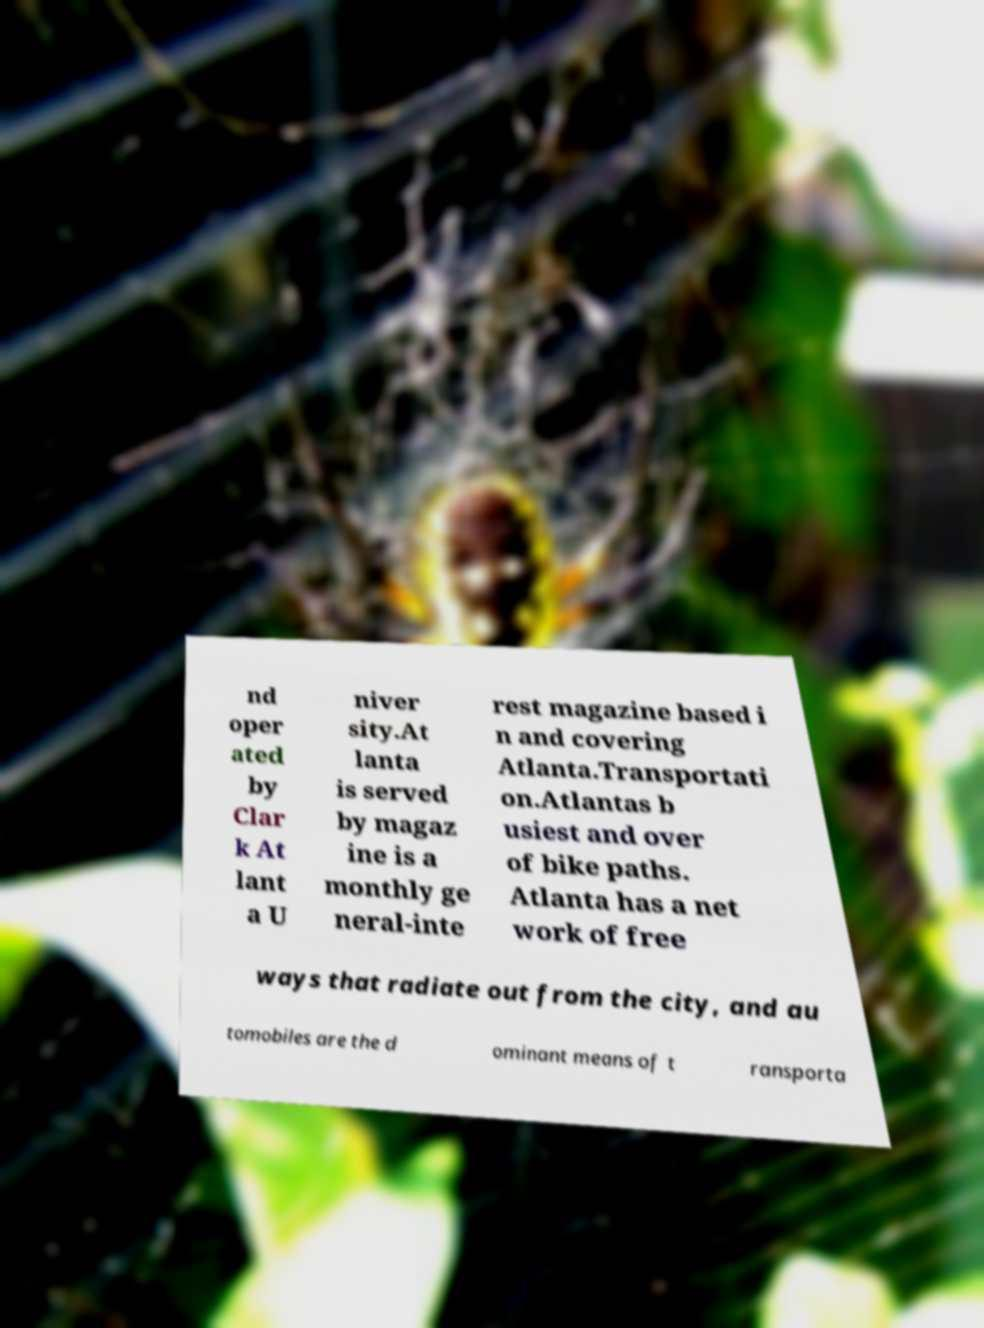There's text embedded in this image that I need extracted. Can you transcribe it verbatim? nd oper ated by Clar k At lant a U niver sity.At lanta is served by magaz ine is a monthly ge neral-inte rest magazine based i n and covering Atlanta.Transportati on.Atlantas b usiest and over of bike paths. Atlanta has a net work of free ways that radiate out from the city, and au tomobiles are the d ominant means of t ransporta 